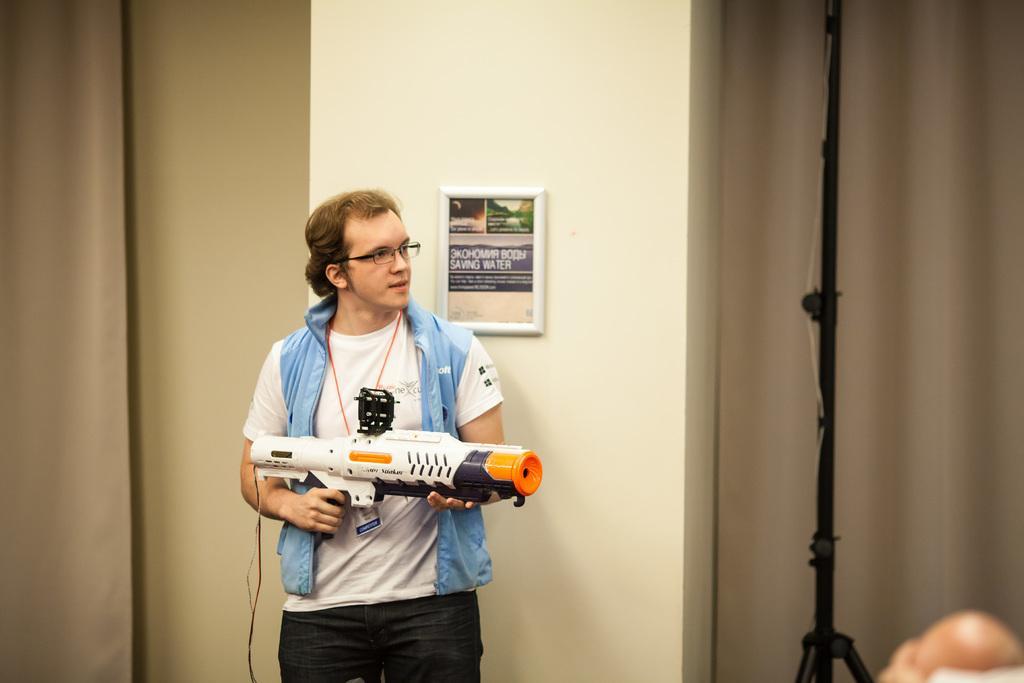In one or two sentences, can you explain what this image depicts? In this image there is a person standing and holding a Nerf super soaker hydro cannon, and in the background there is a frame attached to the wall, tripod stand, curtains. 